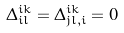Convert formula to latex. <formula><loc_0><loc_0><loc_500><loc_500>\Delta _ { i l } ^ { i k } = \Delta _ { j l , i } ^ { i k } = 0</formula> 